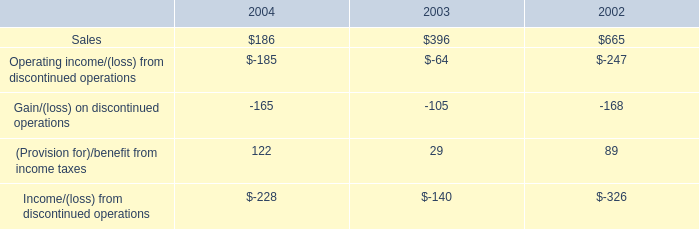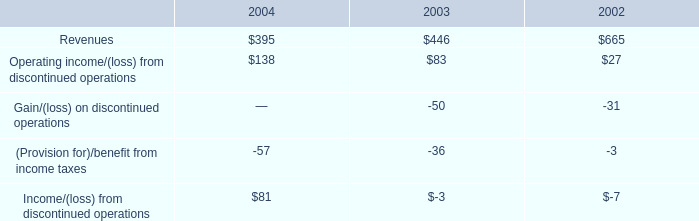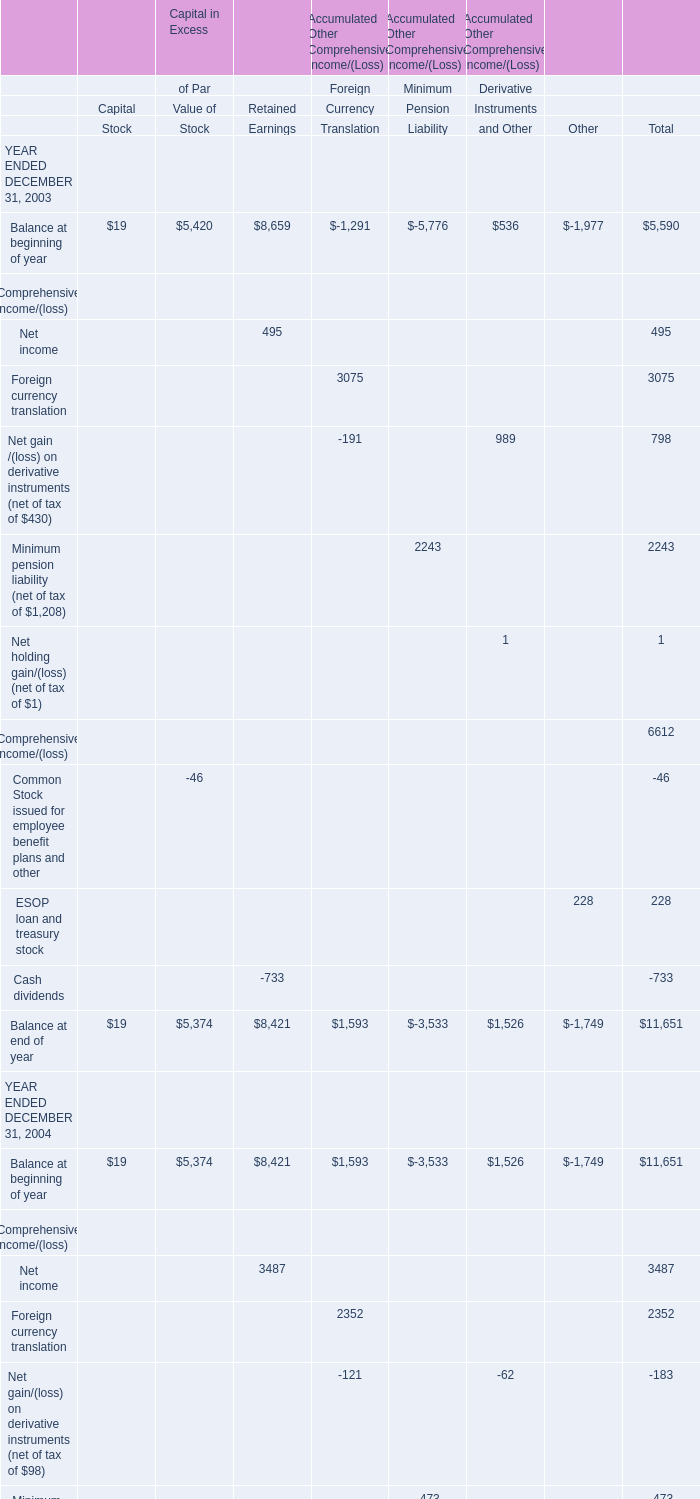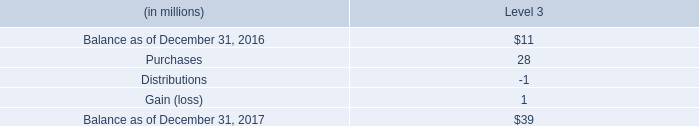What is the average of Balance at beginning of year ENDED DECEMBER 31, 2003 and Balance at beginning of year ENDED DECEMBER 31, 2004 in terms of Capital and Stock? 
Computations: ((19 + 19) / 2)
Answer: 19.0. 